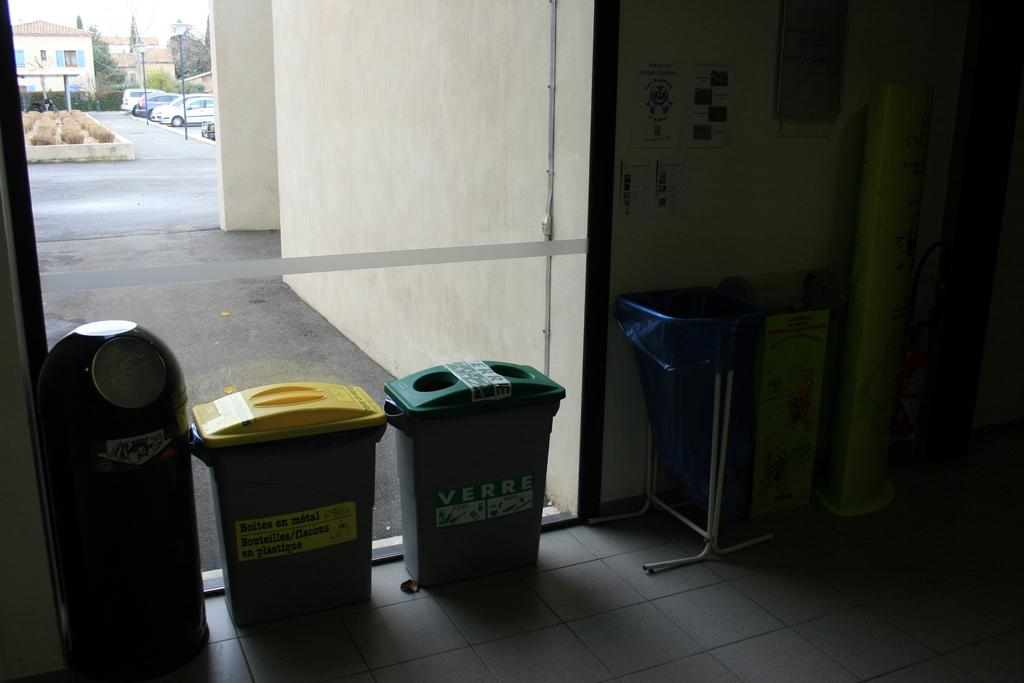Provide a one-sentence caption for the provided image. A glass wall with a trashcan and recycling bins lined up against it. 